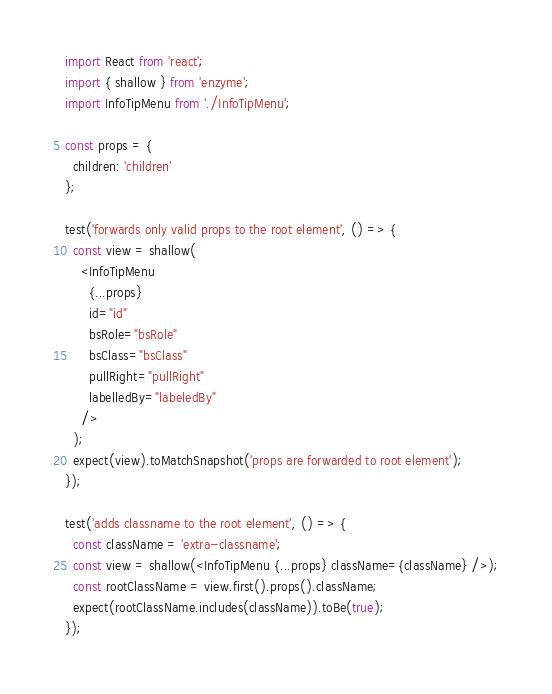<code> <loc_0><loc_0><loc_500><loc_500><_JavaScript_>import React from 'react';
import { shallow } from 'enzyme';
import InfoTipMenu from './InfoTipMenu';

const props = {
  children: 'children'
};

test('forwards only valid props to the root element', () => {
  const view = shallow(
    <InfoTipMenu
      {...props}
      id="id"
      bsRole="bsRole"
      bsClass="bsClass"
      pullRight="pullRight"
      labelledBy="labeledBy"
    />
  );
  expect(view).toMatchSnapshot('props are forwarded to root element');
});

test('adds classname to the root element', () => {
  const className = 'extra-classname';
  const view = shallow(<InfoTipMenu {...props} className={className} />);
  const rootClassName = view.first().props().className;
  expect(rootClassName.includes(className)).toBe(true);
});
</code> 